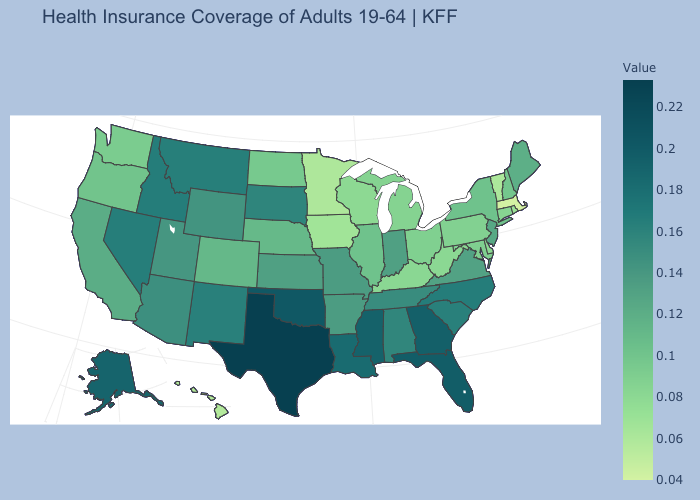Does South Dakota have the highest value in the MidWest?
Answer briefly. Yes. Does New Jersey have the highest value in the Northeast?
Short answer required. Yes. Among the states that border Louisiana , which have the highest value?
Be succinct. Texas. Does North Carolina have the lowest value in the South?
Answer briefly. No. Does West Virginia have a lower value than Idaho?
Quick response, please. Yes. Among the states that border Maryland , does West Virginia have the lowest value?
Answer briefly. Yes. 